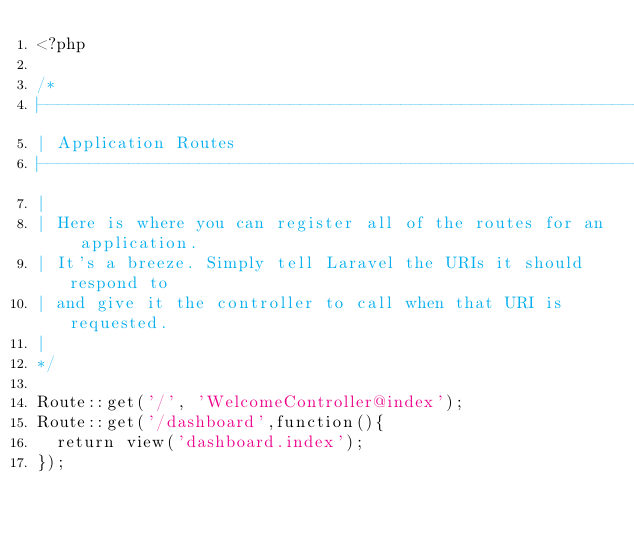Convert code to text. <code><loc_0><loc_0><loc_500><loc_500><_PHP_><?php

/*
|--------------------------------------------------------------------------
| Application Routes
|--------------------------------------------------------------------------
|
| Here is where you can register all of the routes for an application.
| It's a breeze. Simply tell Laravel the URIs it should respond to
| and give it the controller to call when that URI is requested.
|
*/

Route::get('/', 'WelcomeController@index');
Route::get('/dashboard',function(){
	return view('dashboard.index');
});</code> 